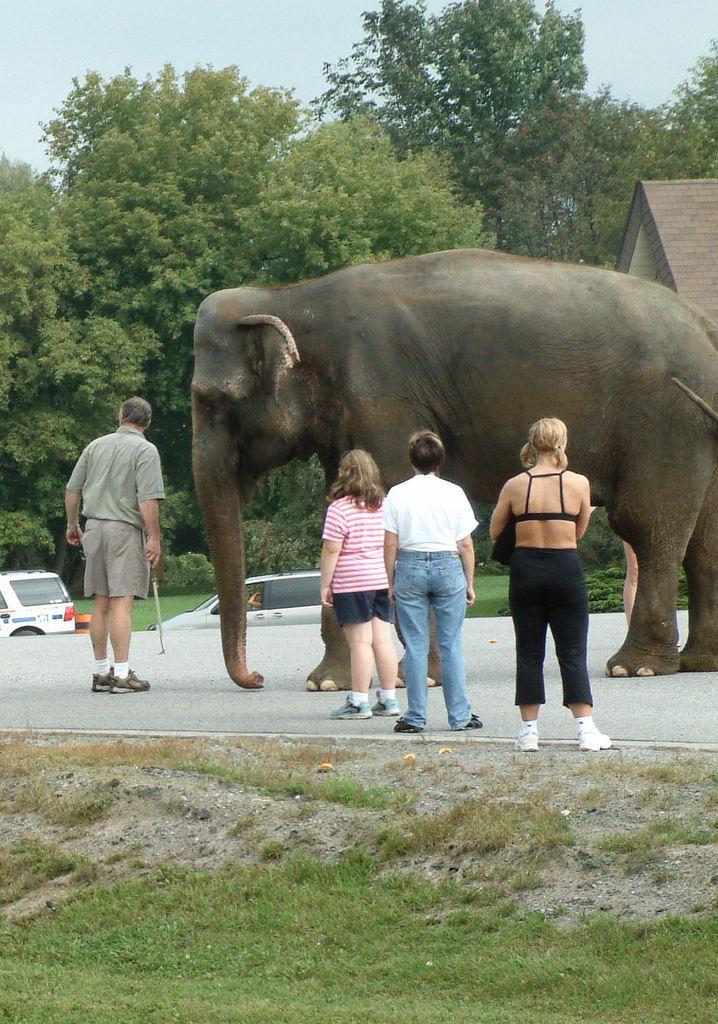Describe this image in one or two sentences. In this image i can see an elephant and a group of people are standing on the road. I can also see there are couple of trees and vehicles. 